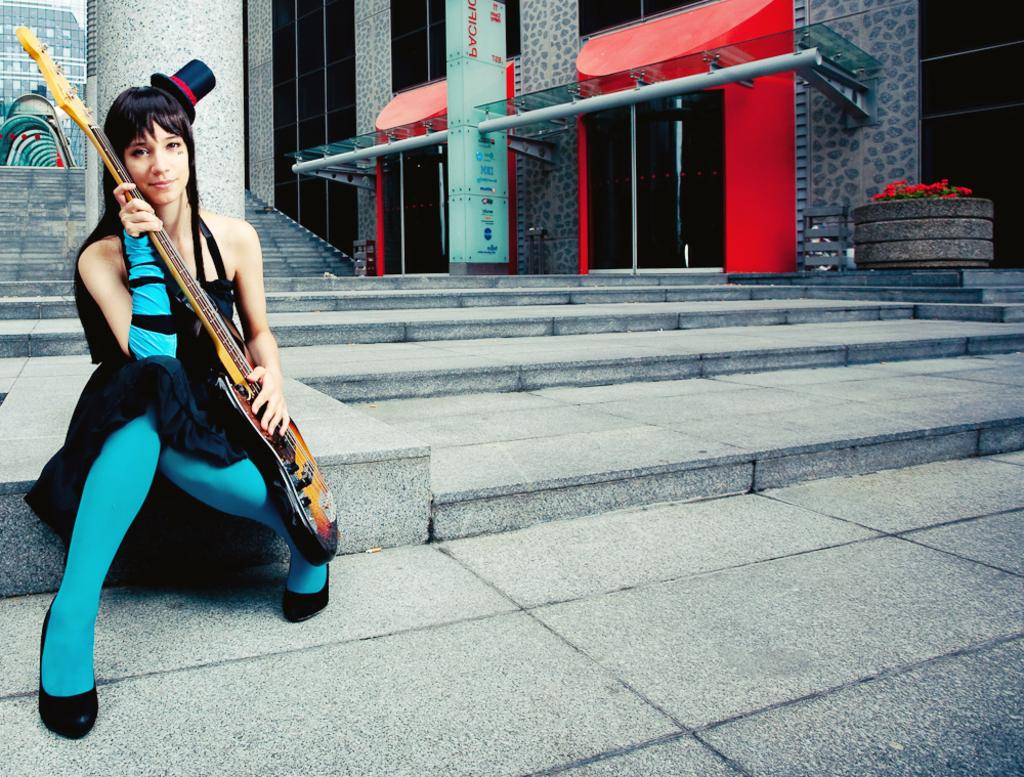Who is present in the image? There is a woman in the image. What is the woman doing in the image? The woman is seated in the image. What object is the woman holding in her hand? The woman is holding a guitar in her hand. What architectural feature can be seen in the image? There are stairs visible in the image. What type of throat condition does the woman have in the image? There is no indication of any throat condition in the image; the woman is simply holding a guitar. 